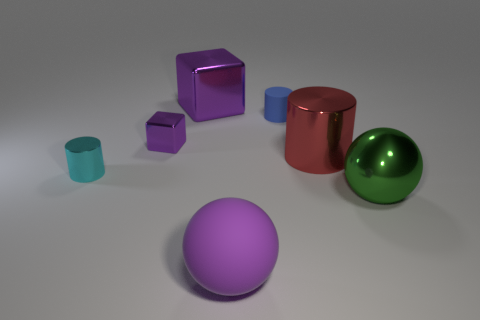Add 3 blue matte cylinders. How many objects exist? 10 Subtract all cylinders. How many objects are left? 4 Subtract 0 green blocks. How many objects are left? 7 Subtract all small purple metallic balls. Subtract all big green shiny things. How many objects are left? 6 Add 2 tiny objects. How many tiny objects are left? 5 Add 1 tiny blue metallic cubes. How many tiny blue metallic cubes exist? 1 